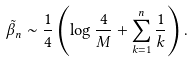<formula> <loc_0><loc_0><loc_500><loc_500>\tilde { \beta } _ { n } \sim \frac { 1 } { 4 } \left ( \log \frac { 4 } { M } + \sum _ { k = 1 } ^ { n } \frac { 1 } { k } \right ) .</formula> 